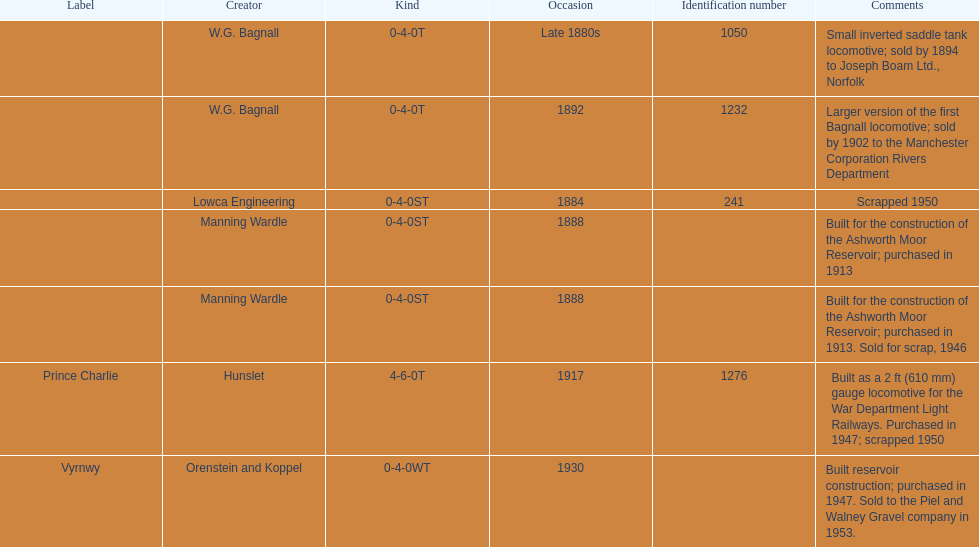What was the last locomotive? Vyrnwy. 